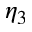Convert formula to latex. <formula><loc_0><loc_0><loc_500><loc_500>\eta _ { 3 }</formula> 